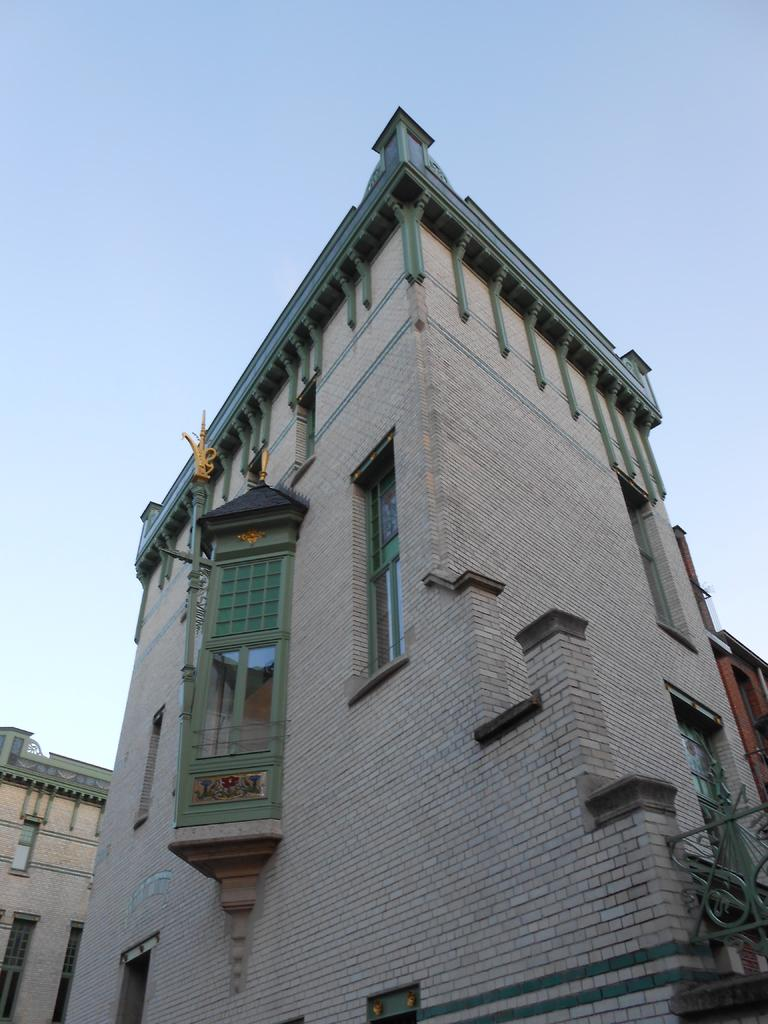What is the main structure in the image? There is a tall building in the image. What can be observed about the tall building's appearance? The tall building has many windows and is made up of bricks. Are there any other buildings in the image? Yes, there are two other buildings on either side of the tall building. What type of fang can be seen on the tall building in the image? There are no fangs present on the tall building in the image. How does the beginner learn to build such a tall building in the image? The image does not provide information about how the building was constructed or who built it. 